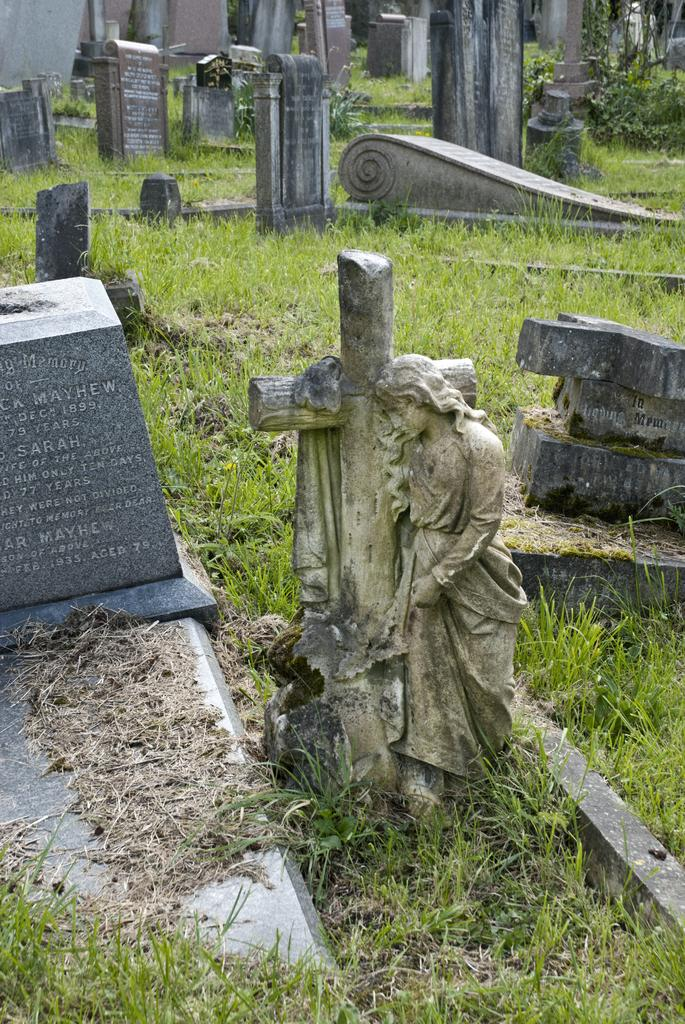What type of location is depicted in the image? The image contains graveyards. How many graves can be seen in the image? There are many graves in the graveyards. What additional feature is present in the image? There is a statue in the image. What type of vegetation is visible at the bottom of the image? Green grass is present at the bottom of the image. What type of drum is being played by the farmer in the image? There is no farmer or drum present in the image; it features graveyards, graves, a statue, and green grass. How does the breath of the person in the image affect the surrounding environment? There is no person present in the image, so their breath cannot affect the environment. 